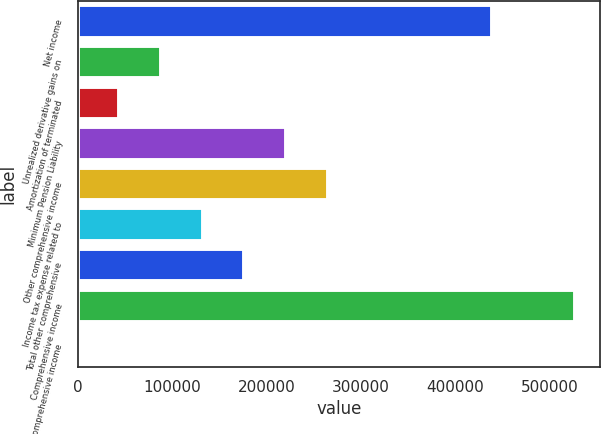Convert chart to OTSL. <chart><loc_0><loc_0><loc_500><loc_500><bar_chart><fcel>Net income<fcel>Unrealized derivative gains on<fcel>Amortization of terminated<fcel>Minimum Pension Liability<fcel>Other comprehensive income<fcel>Income tax expense related to<fcel>Total other comprehensive<fcel>Comprehensive income<fcel>Less Comprehensive income<nl><fcel>438873<fcel>88393.6<fcel>44197.7<fcel>220981<fcel>265177<fcel>132590<fcel>176785<fcel>527265<fcel>1.74<nl></chart> 